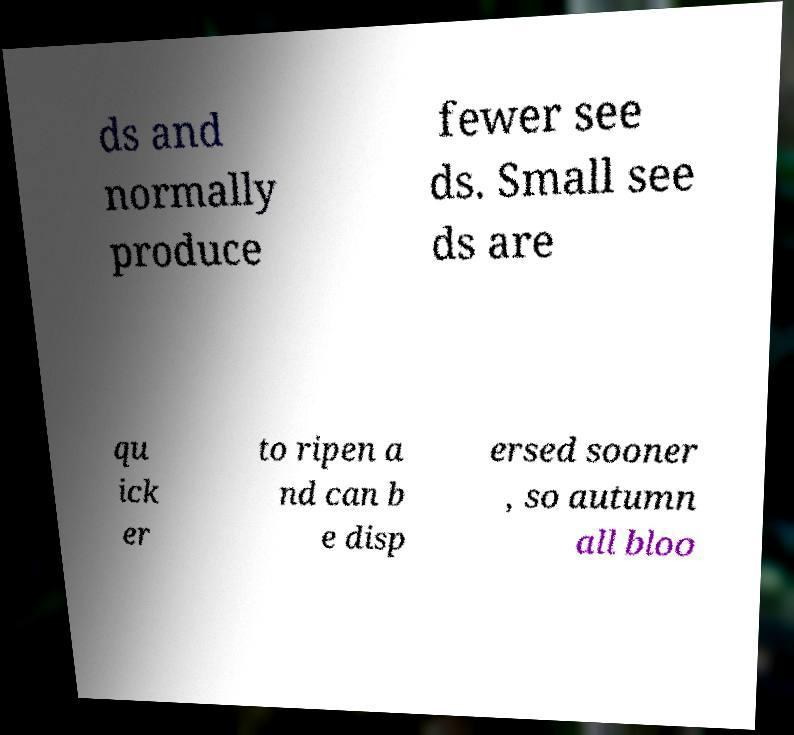Could you extract and type out the text from this image? ds and normally produce fewer see ds. Small see ds are qu ick er to ripen a nd can b e disp ersed sooner , so autumn all bloo 